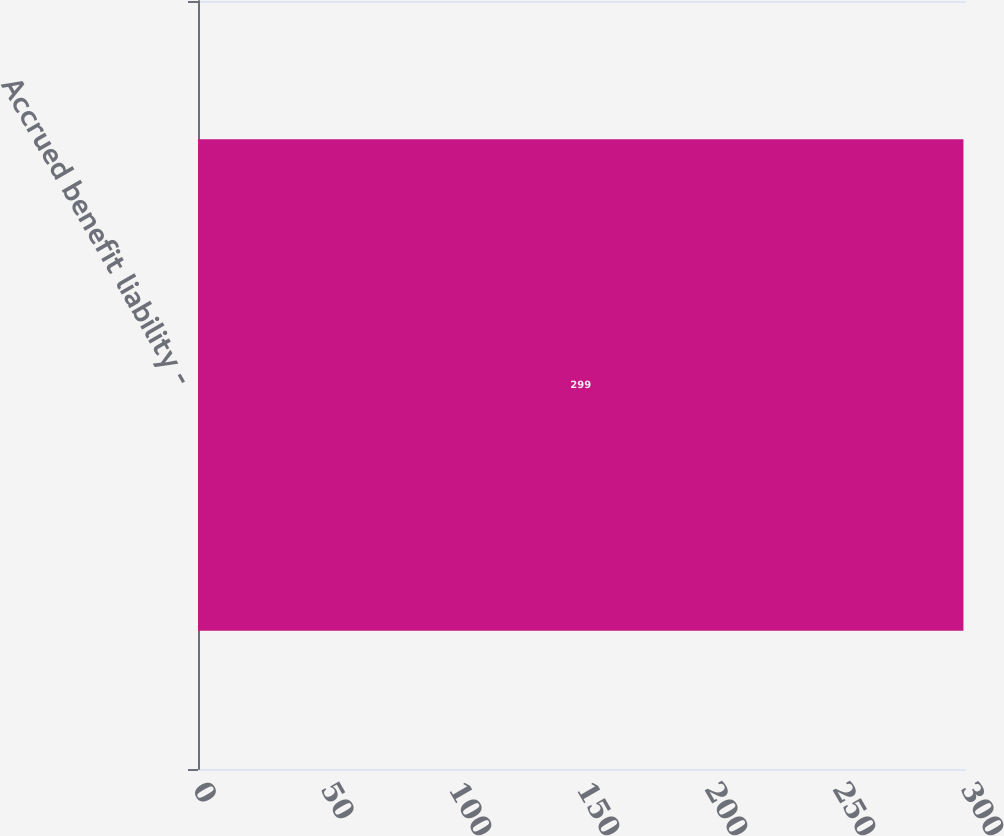Convert chart to OTSL. <chart><loc_0><loc_0><loc_500><loc_500><bar_chart><fcel>Accrued benefit liability -<nl><fcel>299<nl></chart> 